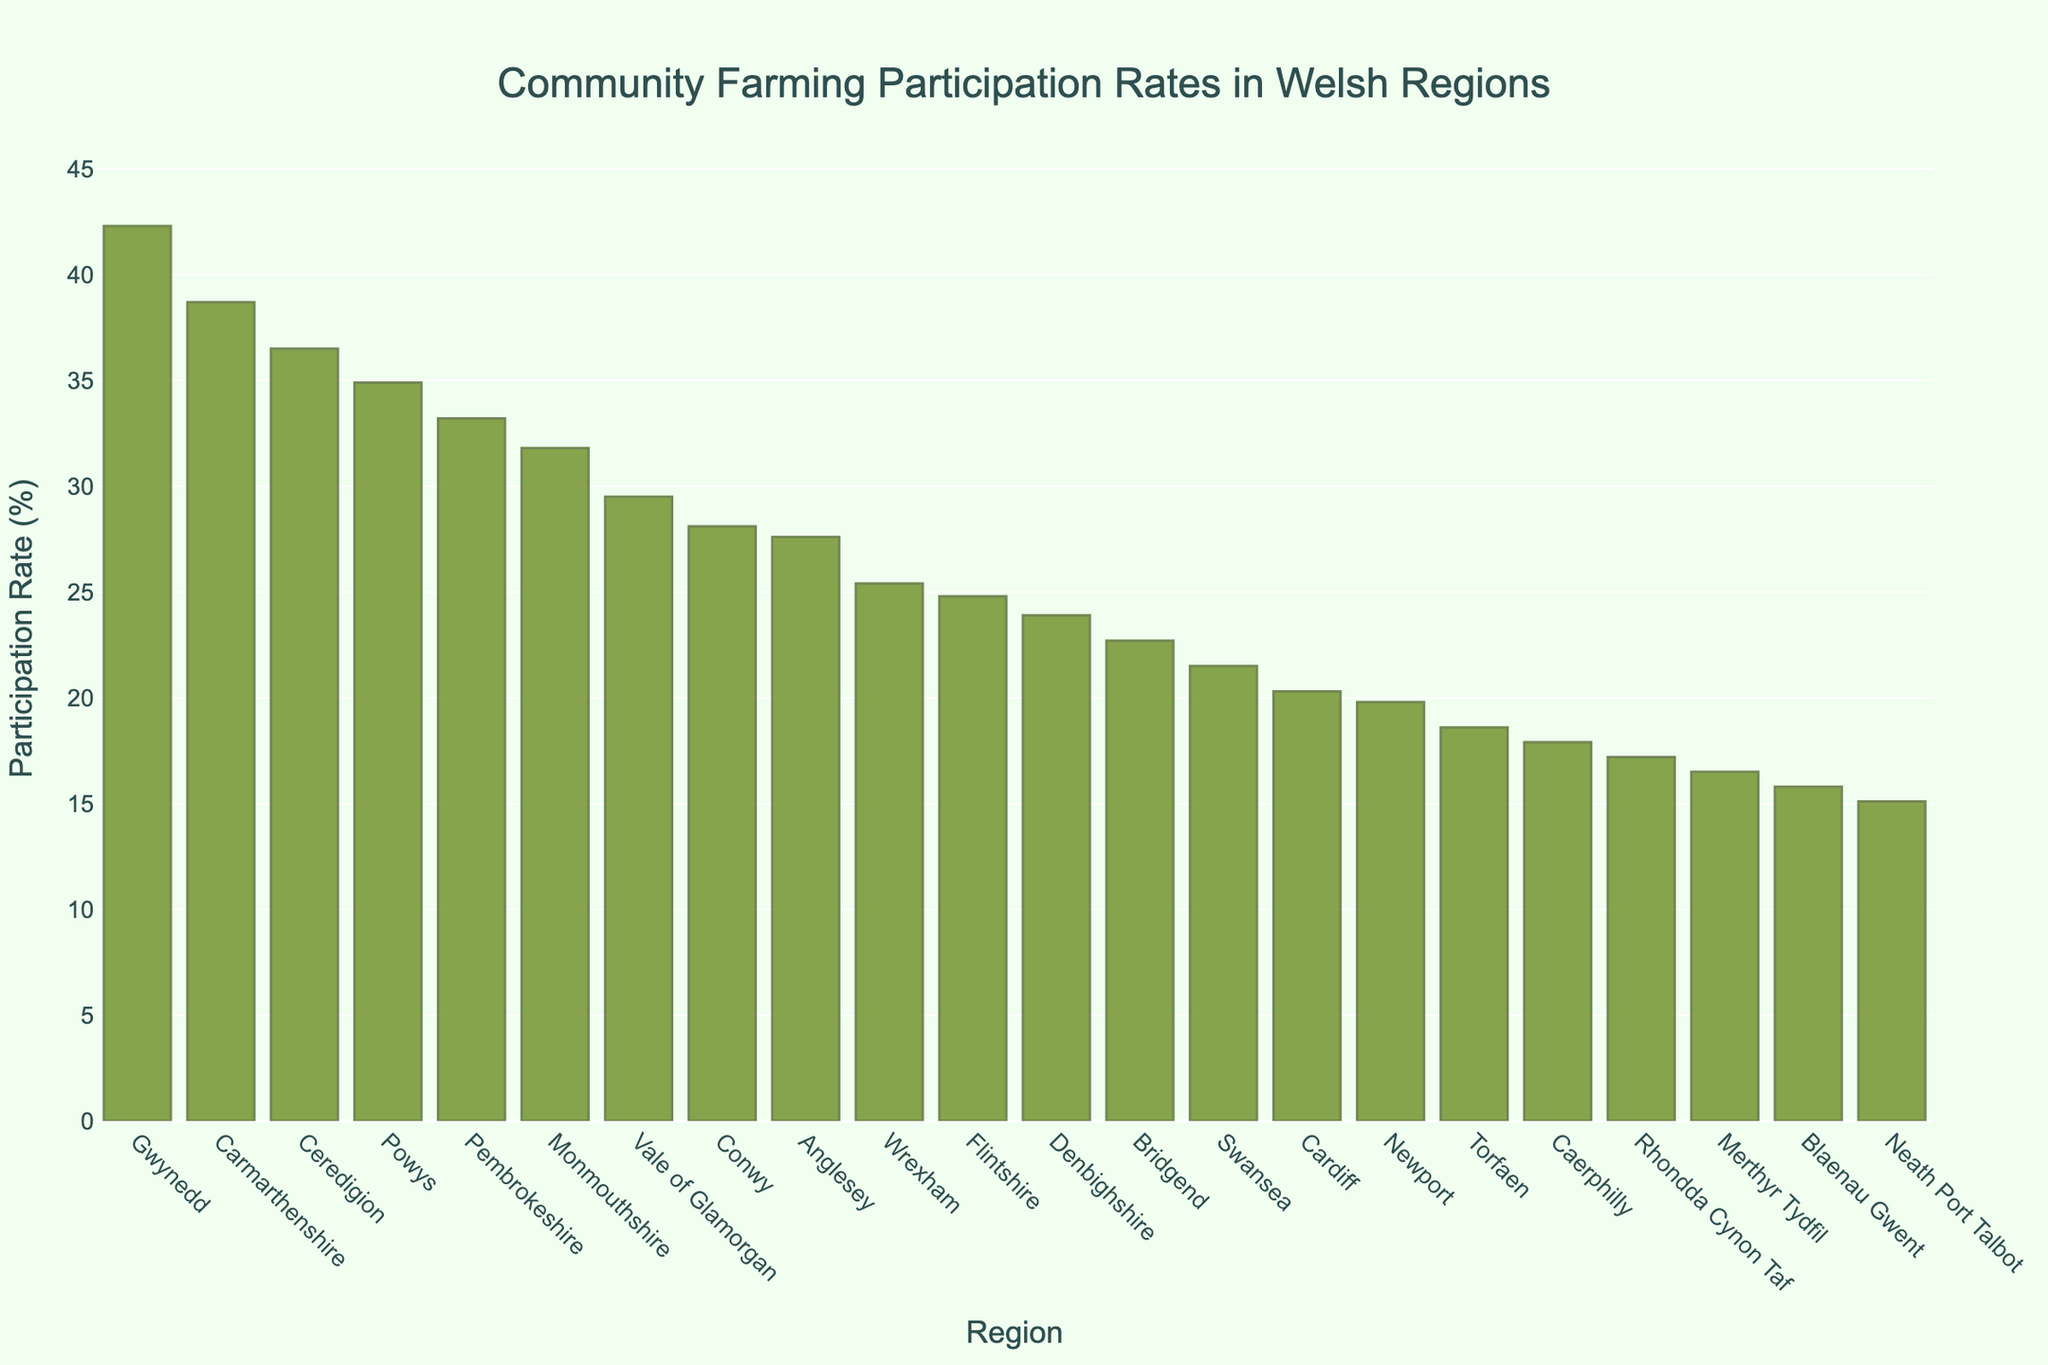What region has the highest participation rate in community farming initiatives? The bar chart shows the participation rates of different Welsh regions. The tallest bar represents Gwynedd, indicating it has the highest participation rate.
Answer: Gwynedd Which region has the lowest participation rate in community farming initiatives? The bar chart shows the participation rates of different Welsh regions. The shortest bar represents Neath Port Talbot, indicating it has the lowest participation rate.
Answer: Neath Port Talbot How many regions have a participation rate above 30%? Count the number of bars with heights exceeding the 30% mark.
Answer: 5 What is the difference in participation rates between Gwynedd and Pembrokeshire? The participation rate for Gwynedd is 42.3%, and for Pembrokeshire, it is 33.2%. Subtract the smaller rate from the larger. 42.3% - 33.2% = 9.1%
Answer: 9.1% Is the participation rate of Ceredigion greater than Monmouthshire? Compare the heights of the bars for Ceredigion and Monmouthshire. The bar for Ceredigion is taller than that for Monmouthshire (36.5% vs. 31.8%).
Answer: Yes Which regions have participation rates between 20% and 25%? Identify the bars within the range of 20% to 25%. These regions are Wrexham, Flintshire, and Denbighshire.
Answer: Wrexham, Flintshire, Denbighshire What is the average participation rate of the top three regions? The top three regions by participation rate are Gwynedd (42.3%), Carmarthenshire (38.7%), and Ceredigion (36.5%). Calculate the average: (42.3 + 38.7 + 36.5) / 3 = 39.17%
Answer: 39.17% Which region has a participation rate closest to 25%? Look at the regions near the 25% mark and compare. Wrexham has a participation rate of 25.4%, which is closest to 25%.
Answer: Wrexham How does the participation rate of Blaenau Gwent compare to that of Cardiff? The bar corresponding to Blaenau Gwent (15.8%) is shorter than the bar for Cardiff (20.3%). So, Blaenau Gwent has a lower participation rate.
Answer: Lower What is the median participation rate across all regions? First, list the participation rates in order: [15.1, 15.8, 16.5, 17.2, 17.9, 18.6, 19.8, 20.3, 21.5, 22.7, 23.9, 24.8, 25.4, 27.6, 28.1, 29.5, 31.8, 33.2, 34.9, 36.5, 38.7, 42.3]. There are 22 values; the median is the average of the 11th and 12th values: (23.9 + 24.8) / 2 = 24.35%.
Answer: 24.35% 